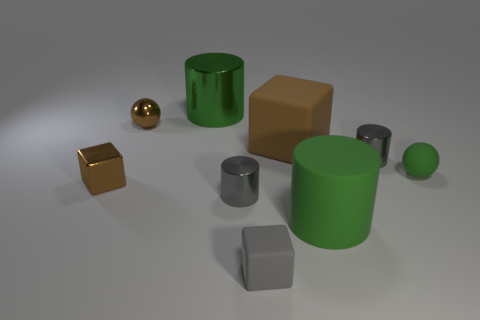Subtract all brown shiny blocks. How many blocks are left? 2 Subtract all brown balls. How many balls are left? 1 Subtract all cubes. How many objects are left? 6 Subtract all red blocks. How many gray cylinders are left? 2 Add 1 matte blocks. How many objects exist? 10 Subtract all brown balls. Subtract all red blocks. How many balls are left? 1 Subtract all green metallic cylinders. Subtract all big yellow metal things. How many objects are left? 8 Add 4 tiny gray rubber cubes. How many tiny gray rubber cubes are left? 5 Add 8 large blocks. How many large blocks exist? 9 Subtract 1 green cylinders. How many objects are left? 8 